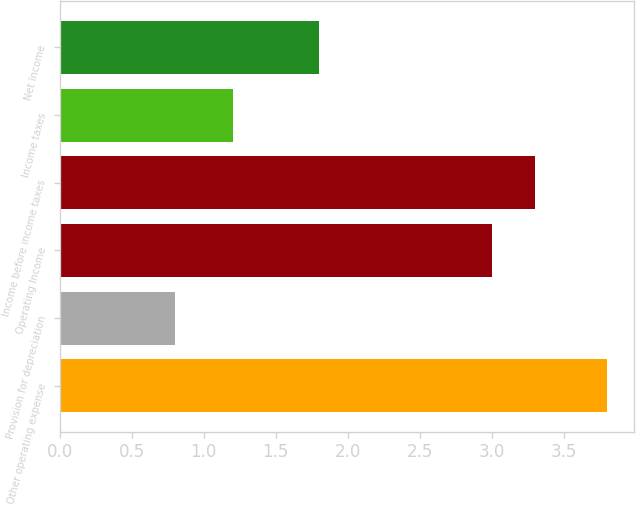<chart> <loc_0><loc_0><loc_500><loc_500><bar_chart><fcel>Other operating expense<fcel>Provision for depreciation<fcel>Operating Income<fcel>Income before income taxes<fcel>Income taxes<fcel>Net Income<nl><fcel>3.8<fcel>0.8<fcel>3<fcel>3.3<fcel>1.2<fcel>1.8<nl></chart> 